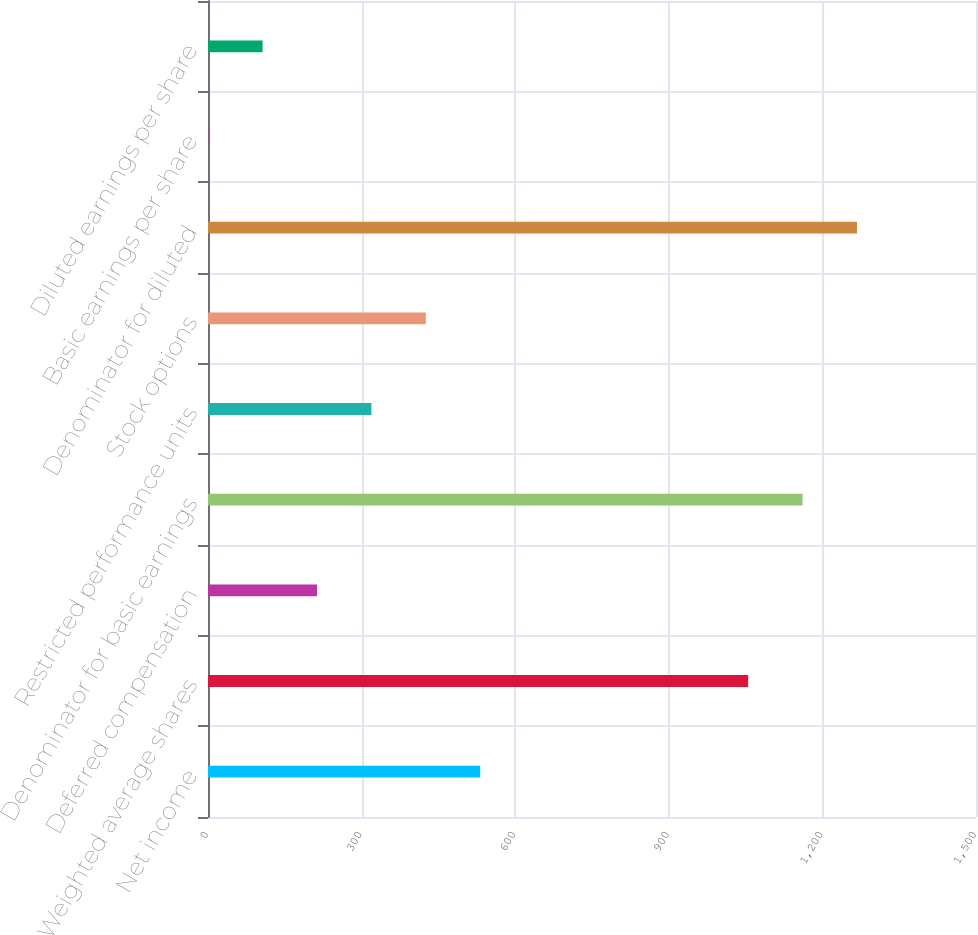Convert chart to OTSL. <chart><loc_0><loc_0><loc_500><loc_500><bar_chart><fcel>Net income<fcel>Weighted average shares<fcel>Deferred compensation<fcel>Denominator for basic earnings<fcel>Restricted performance units<fcel>Stock options<fcel>Denominator for diluted<fcel>Basic earnings per share<fcel>Diluted earnings per share<nl><fcel>531.66<fcel>1055<fcel>212.88<fcel>1161.26<fcel>319.14<fcel>425.4<fcel>1267.52<fcel>0.36<fcel>106.62<nl></chart> 